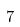<formula> <loc_0><loc_0><loc_500><loc_500>7</formula> 